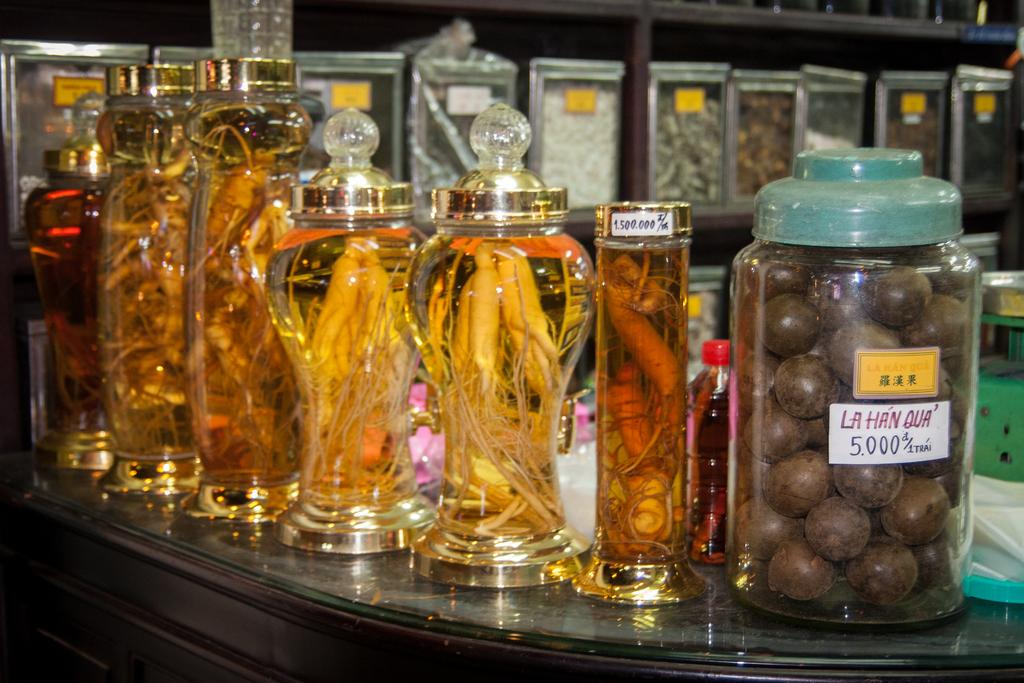<image>
Relay a brief, clear account of the picture shown. the number 5 is on the glass bottle next to many others 